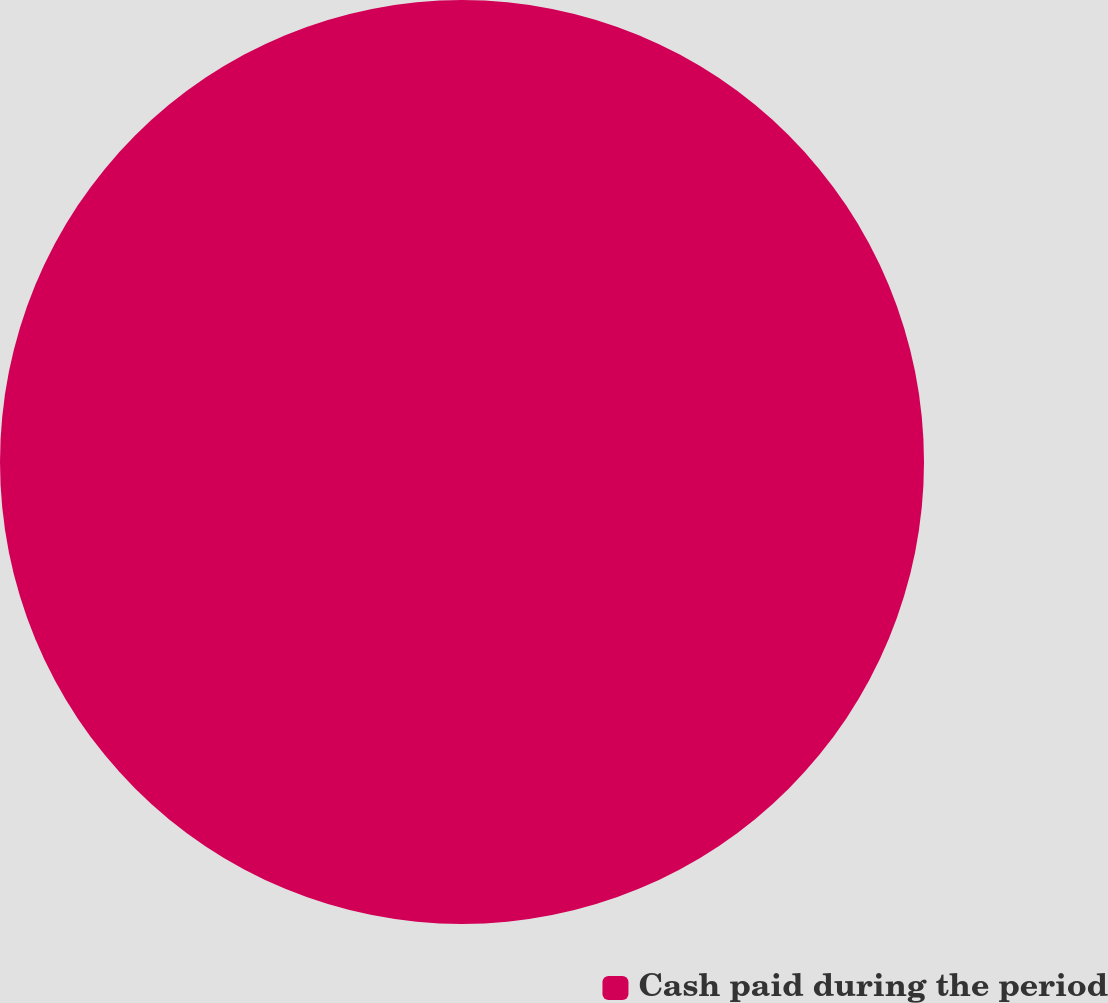<chart> <loc_0><loc_0><loc_500><loc_500><pie_chart><fcel>Cash paid during the period<nl><fcel>100.0%<nl></chart> 